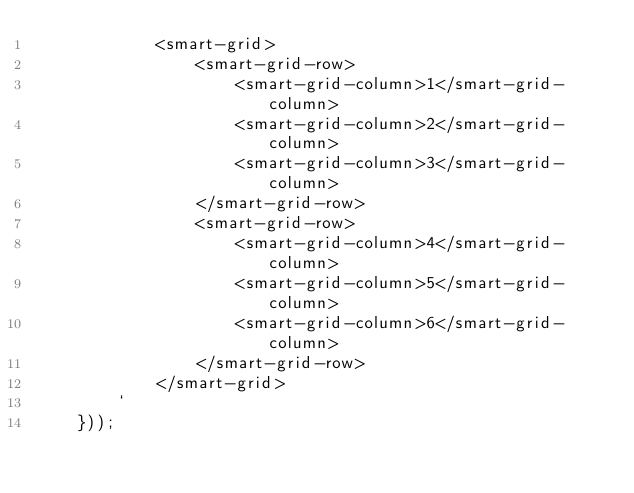<code> <loc_0><loc_0><loc_500><loc_500><_TypeScript_>            <smart-grid>
                <smart-grid-row>
                    <smart-grid-column>1</smart-grid-column>
                    <smart-grid-column>2</smart-grid-column>
                    <smart-grid-column>3</smart-grid-column>
                </smart-grid-row>
                <smart-grid-row>
                    <smart-grid-column>4</smart-grid-column>
                    <smart-grid-column>5</smart-grid-column>
                    <smart-grid-column>6</smart-grid-column>
                </smart-grid-row>
            </smart-grid>
        `
    }));
</code> 